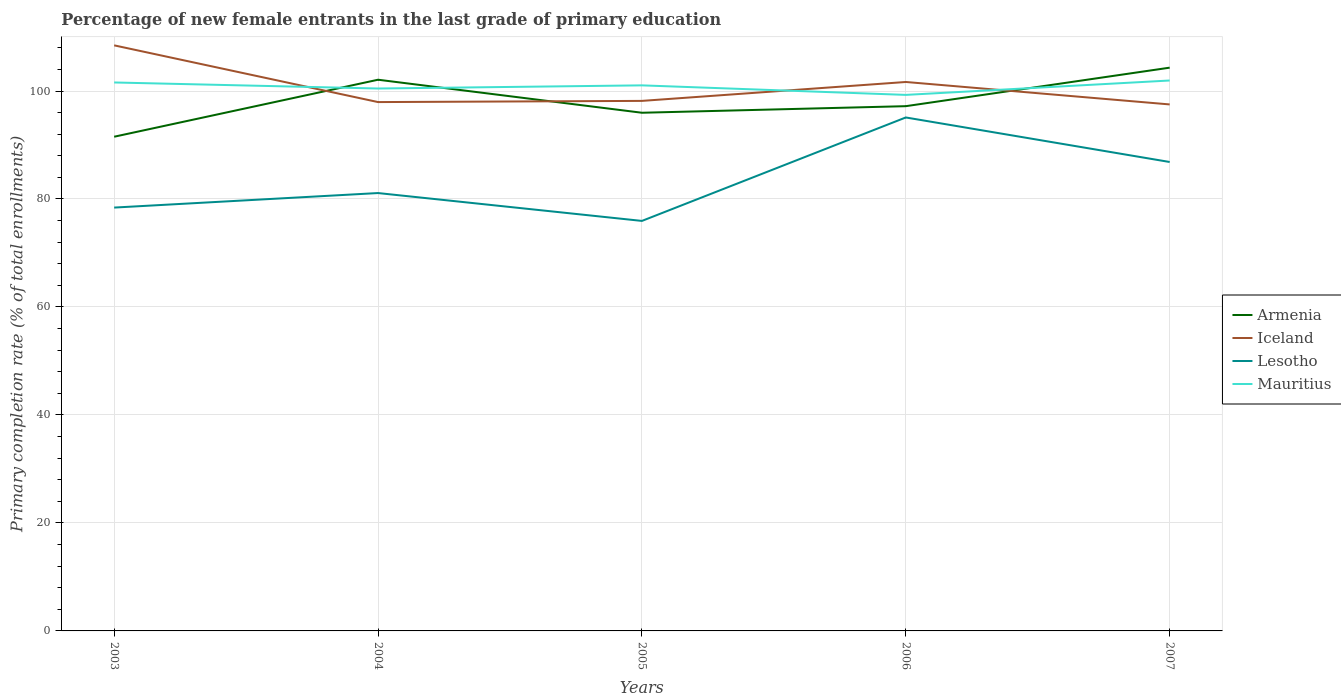Does the line corresponding to Iceland intersect with the line corresponding to Armenia?
Your answer should be very brief. Yes. Is the number of lines equal to the number of legend labels?
Make the answer very short. Yes. Across all years, what is the maximum percentage of new female entrants in Lesotho?
Ensure brevity in your answer.  75.94. In which year was the percentage of new female entrants in Lesotho maximum?
Offer a very short reply. 2005. What is the total percentage of new female entrants in Mauritius in the graph?
Your answer should be very brief. -2.67. What is the difference between the highest and the second highest percentage of new female entrants in Iceland?
Provide a short and direct response. 10.94. What is the difference between the highest and the lowest percentage of new female entrants in Lesotho?
Give a very brief answer. 2. How many years are there in the graph?
Offer a terse response. 5. What is the difference between two consecutive major ticks on the Y-axis?
Your answer should be compact. 20. Are the values on the major ticks of Y-axis written in scientific E-notation?
Your answer should be compact. No. Does the graph contain any zero values?
Your answer should be compact. No. Does the graph contain grids?
Your response must be concise. Yes. How many legend labels are there?
Give a very brief answer. 4. How are the legend labels stacked?
Offer a terse response. Vertical. What is the title of the graph?
Provide a succinct answer. Percentage of new female entrants in the last grade of primary education. What is the label or title of the X-axis?
Keep it short and to the point. Years. What is the label or title of the Y-axis?
Offer a terse response. Primary completion rate (% of total enrollments). What is the Primary completion rate (% of total enrollments) of Armenia in 2003?
Offer a terse response. 91.53. What is the Primary completion rate (% of total enrollments) of Iceland in 2003?
Offer a terse response. 108.46. What is the Primary completion rate (% of total enrollments) in Lesotho in 2003?
Ensure brevity in your answer.  78.41. What is the Primary completion rate (% of total enrollments) of Mauritius in 2003?
Give a very brief answer. 101.58. What is the Primary completion rate (% of total enrollments) in Armenia in 2004?
Offer a very short reply. 102.09. What is the Primary completion rate (% of total enrollments) of Iceland in 2004?
Offer a very short reply. 97.95. What is the Primary completion rate (% of total enrollments) of Lesotho in 2004?
Your answer should be compact. 81.1. What is the Primary completion rate (% of total enrollments) in Mauritius in 2004?
Keep it short and to the point. 100.46. What is the Primary completion rate (% of total enrollments) of Armenia in 2005?
Keep it short and to the point. 95.97. What is the Primary completion rate (% of total enrollments) of Iceland in 2005?
Your answer should be very brief. 98.17. What is the Primary completion rate (% of total enrollments) in Lesotho in 2005?
Your response must be concise. 75.94. What is the Primary completion rate (% of total enrollments) in Mauritius in 2005?
Offer a terse response. 101.05. What is the Primary completion rate (% of total enrollments) in Armenia in 2006?
Provide a short and direct response. 97.19. What is the Primary completion rate (% of total enrollments) of Iceland in 2006?
Offer a terse response. 101.67. What is the Primary completion rate (% of total enrollments) in Lesotho in 2006?
Give a very brief answer. 95.1. What is the Primary completion rate (% of total enrollments) of Mauritius in 2006?
Provide a succinct answer. 99.28. What is the Primary completion rate (% of total enrollments) in Armenia in 2007?
Your answer should be very brief. 104.33. What is the Primary completion rate (% of total enrollments) of Iceland in 2007?
Your response must be concise. 97.52. What is the Primary completion rate (% of total enrollments) of Lesotho in 2007?
Your response must be concise. 86.85. What is the Primary completion rate (% of total enrollments) in Mauritius in 2007?
Provide a short and direct response. 101.95. Across all years, what is the maximum Primary completion rate (% of total enrollments) in Armenia?
Your answer should be very brief. 104.33. Across all years, what is the maximum Primary completion rate (% of total enrollments) in Iceland?
Provide a short and direct response. 108.46. Across all years, what is the maximum Primary completion rate (% of total enrollments) in Lesotho?
Your response must be concise. 95.1. Across all years, what is the maximum Primary completion rate (% of total enrollments) in Mauritius?
Keep it short and to the point. 101.95. Across all years, what is the minimum Primary completion rate (% of total enrollments) of Armenia?
Provide a succinct answer. 91.53. Across all years, what is the minimum Primary completion rate (% of total enrollments) in Iceland?
Provide a short and direct response. 97.52. Across all years, what is the minimum Primary completion rate (% of total enrollments) of Lesotho?
Offer a very short reply. 75.94. Across all years, what is the minimum Primary completion rate (% of total enrollments) of Mauritius?
Provide a short and direct response. 99.28. What is the total Primary completion rate (% of total enrollments) of Armenia in the graph?
Offer a terse response. 491.12. What is the total Primary completion rate (% of total enrollments) of Iceland in the graph?
Your answer should be compact. 503.77. What is the total Primary completion rate (% of total enrollments) in Lesotho in the graph?
Ensure brevity in your answer.  417.41. What is the total Primary completion rate (% of total enrollments) in Mauritius in the graph?
Offer a very short reply. 504.32. What is the difference between the Primary completion rate (% of total enrollments) of Armenia in 2003 and that in 2004?
Offer a terse response. -10.56. What is the difference between the Primary completion rate (% of total enrollments) of Iceland in 2003 and that in 2004?
Your answer should be compact. 10.51. What is the difference between the Primary completion rate (% of total enrollments) in Lesotho in 2003 and that in 2004?
Offer a terse response. -2.69. What is the difference between the Primary completion rate (% of total enrollments) in Mauritius in 2003 and that in 2004?
Your answer should be very brief. 1.12. What is the difference between the Primary completion rate (% of total enrollments) in Armenia in 2003 and that in 2005?
Your answer should be compact. -4.44. What is the difference between the Primary completion rate (% of total enrollments) in Iceland in 2003 and that in 2005?
Make the answer very short. 10.29. What is the difference between the Primary completion rate (% of total enrollments) of Lesotho in 2003 and that in 2005?
Offer a terse response. 2.47. What is the difference between the Primary completion rate (% of total enrollments) of Mauritius in 2003 and that in 2005?
Make the answer very short. 0.53. What is the difference between the Primary completion rate (% of total enrollments) of Armenia in 2003 and that in 2006?
Provide a short and direct response. -5.66. What is the difference between the Primary completion rate (% of total enrollments) in Iceland in 2003 and that in 2006?
Offer a very short reply. 6.78. What is the difference between the Primary completion rate (% of total enrollments) in Lesotho in 2003 and that in 2006?
Your answer should be very brief. -16.69. What is the difference between the Primary completion rate (% of total enrollments) of Mauritius in 2003 and that in 2006?
Provide a short and direct response. 2.3. What is the difference between the Primary completion rate (% of total enrollments) in Armenia in 2003 and that in 2007?
Give a very brief answer. -12.79. What is the difference between the Primary completion rate (% of total enrollments) in Iceland in 2003 and that in 2007?
Offer a terse response. 10.94. What is the difference between the Primary completion rate (% of total enrollments) in Lesotho in 2003 and that in 2007?
Make the answer very short. -8.44. What is the difference between the Primary completion rate (% of total enrollments) of Mauritius in 2003 and that in 2007?
Offer a terse response. -0.36. What is the difference between the Primary completion rate (% of total enrollments) of Armenia in 2004 and that in 2005?
Your answer should be very brief. 6.12. What is the difference between the Primary completion rate (% of total enrollments) in Iceland in 2004 and that in 2005?
Your answer should be compact. -0.22. What is the difference between the Primary completion rate (% of total enrollments) in Lesotho in 2004 and that in 2005?
Provide a short and direct response. 5.16. What is the difference between the Primary completion rate (% of total enrollments) of Mauritius in 2004 and that in 2005?
Your response must be concise. -0.59. What is the difference between the Primary completion rate (% of total enrollments) in Armenia in 2004 and that in 2006?
Your answer should be compact. 4.9. What is the difference between the Primary completion rate (% of total enrollments) of Iceland in 2004 and that in 2006?
Provide a succinct answer. -3.72. What is the difference between the Primary completion rate (% of total enrollments) in Lesotho in 2004 and that in 2006?
Make the answer very short. -14. What is the difference between the Primary completion rate (% of total enrollments) in Mauritius in 2004 and that in 2006?
Offer a terse response. 1.18. What is the difference between the Primary completion rate (% of total enrollments) of Armenia in 2004 and that in 2007?
Make the answer very short. -2.23. What is the difference between the Primary completion rate (% of total enrollments) of Iceland in 2004 and that in 2007?
Your response must be concise. 0.44. What is the difference between the Primary completion rate (% of total enrollments) of Lesotho in 2004 and that in 2007?
Ensure brevity in your answer.  -5.75. What is the difference between the Primary completion rate (% of total enrollments) of Mauritius in 2004 and that in 2007?
Your answer should be very brief. -1.48. What is the difference between the Primary completion rate (% of total enrollments) in Armenia in 2005 and that in 2006?
Offer a terse response. -1.22. What is the difference between the Primary completion rate (% of total enrollments) in Iceland in 2005 and that in 2006?
Give a very brief answer. -3.5. What is the difference between the Primary completion rate (% of total enrollments) in Lesotho in 2005 and that in 2006?
Give a very brief answer. -19.16. What is the difference between the Primary completion rate (% of total enrollments) in Mauritius in 2005 and that in 2006?
Make the answer very short. 1.77. What is the difference between the Primary completion rate (% of total enrollments) of Armenia in 2005 and that in 2007?
Offer a terse response. -8.35. What is the difference between the Primary completion rate (% of total enrollments) in Iceland in 2005 and that in 2007?
Keep it short and to the point. 0.65. What is the difference between the Primary completion rate (% of total enrollments) of Lesotho in 2005 and that in 2007?
Your answer should be very brief. -10.91. What is the difference between the Primary completion rate (% of total enrollments) in Mauritius in 2005 and that in 2007?
Provide a succinct answer. -0.9. What is the difference between the Primary completion rate (% of total enrollments) in Armenia in 2006 and that in 2007?
Offer a very short reply. -7.13. What is the difference between the Primary completion rate (% of total enrollments) of Iceland in 2006 and that in 2007?
Provide a succinct answer. 4.16. What is the difference between the Primary completion rate (% of total enrollments) in Lesotho in 2006 and that in 2007?
Your answer should be compact. 8.25. What is the difference between the Primary completion rate (% of total enrollments) of Mauritius in 2006 and that in 2007?
Your response must be concise. -2.67. What is the difference between the Primary completion rate (% of total enrollments) of Armenia in 2003 and the Primary completion rate (% of total enrollments) of Iceland in 2004?
Offer a terse response. -6.42. What is the difference between the Primary completion rate (% of total enrollments) of Armenia in 2003 and the Primary completion rate (% of total enrollments) of Lesotho in 2004?
Your answer should be compact. 10.43. What is the difference between the Primary completion rate (% of total enrollments) in Armenia in 2003 and the Primary completion rate (% of total enrollments) in Mauritius in 2004?
Ensure brevity in your answer.  -8.93. What is the difference between the Primary completion rate (% of total enrollments) in Iceland in 2003 and the Primary completion rate (% of total enrollments) in Lesotho in 2004?
Offer a terse response. 27.36. What is the difference between the Primary completion rate (% of total enrollments) in Iceland in 2003 and the Primary completion rate (% of total enrollments) in Mauritius in 2004?
Your answer should be compact. 8. What is the difference between the Primary completion rate (% of total enrollments) of Lesotho in 2003 and the Primary completion rate (% of total enrollments) of Mauritius in 2004?
Offer a very short reply. -22.05. What is the difference between the Primary completion rate (% of total enrollments) in Armenia in 2003 and the Primary completion rate (% of total enrollments) in Iceland in 2005?
Your answer should be compact. -6.64. What is the difference between the Primary completion rate (% of total enrollments) of Armenia in 2003 and the Primary completion rate (% of total enrollments) of Lesotho in 2005?
Offer a terse response. 15.59. What is the difference between the Primary completion rate (% of total enrollments) in Armenia in 2003 and the Primary completion rate (% of total enrollments) in Mauritius in 2005?
Offer a terse response. -9.51. What is the difference between the Primary completion rate (% of total enrollments) of Iceland in 2003 and the Primary completion rate (% of total enrollments) of Lesotho in 2005?
Give a very brief answer. 32.52. What is the difference between the Primary completion rate (% of total enrollments) in Iceland in 2003 and the Primary completion rate (% of total enrollments) in Mauritius in 2005?
Offer a very short reply. 7.41. What is the difference between the Primary completion rate (% of total enrollments) in Lesotho in 2003 and the Primary completion rate (% of total enrollments) in Mauritius in 2005?
Give a very brief answer. -22.64. What is the difference between the Primary completion rate (% of total enrollments) of Armenia in 2003 and the Primary completion rate (% of total enrollments) of Iceland in 2006?
Offer a terse response. -10.14. What is the difference between the Primary completion rate (% of total enrollments) of Armenia in 2003 and the Primary completion rate (% of total enrollments) of Lesotho in 2006?
Offer a terse response. -3.57. What is the difference between the Primary completion rate (% of total enrollments) in Armenia in 2003 and the Primary completion rate (% of total enrollments) in Mauritius in 2006?
Give a very brief answer. -7.75. What is the difference between the Primary completion rate (% of total enrollments) in Iceland in 2003 and the Primary completion rate (% of total enrollments) in Lesotho in 2006?
Make the answer very short. 13.36. What is the difference between the Primary completion rate (% of total enrollments) of Iceland in 2003 and the Primary completion rate (% of total enrollments) of Mauritius in 2006?
Offer a terse response. 9.18. What is the difference between the Primary completion rate (% of total enrollments) of Lesotho in 2003 and the Primary completion rate (% of total enrollments) of Mauritius in 2006?
Provide a succinct answer. -20.87. What is the difference between the Primary completion rate (% of total enrollments) of Armenia in 2003 and the Primary completion rate (% of total enrollments) of Iceland in 2007?
Your response must be concise. -5.98. What is the difference between the Primary completion rate (% of total enrollments) of Armenia in 2003 and the Primary completion rate (% of total enrollments) of Lesotho in 2007?
Your response must be concise. 4.68. What is the difference between the Primary completion rate (% of total enrollments) of Armenia in 2003 and the Primary completion rate (% of total enrollments) of Mauritius in 2007?
Your response must be concise. -10.41. What is the difference between the Primary completion rate (% of total enrollments) in Iceland in 2003 and the Primary completion rate (% of total enrollments) in Lesotho in 2007?
Give a very brief answer. 21.6. What is the difference between the Primary completion rate (% of total enrollments) of Iceland in 2003 and the Primary completion rate (% of total enrollments) of Mauritius in 2007?
Your response must be concise. 6.51. What is the difference between the Primary completion rate (% of total enrollments) in Lesotho in 2003 and the Primary completion rate (% of total enrollments) in Mauritius in 2007?
Provide a short and direct response. -23.54. What is the difference between the Primary completion rate (% of total enrollments) in Armenia in 2004 and the Primary completion rate (% of total enrollments) in Iceland in 2005?
Provide a short and direct response. 3.92. What is the difference between the Primary completion rate (% of total enrollments) of Armenia in 2004 and the Primary completion rate (% of total enrollments) of Lesotho in 2005?
Your answer should be very brief. 26.15. What is the difference between the Primary completion rate (% of total enrollments) in Armenia in 2004 and the Primary completion rate (% of total enrollments) in Mauritius in 2005?
Your answer should be very brief. 1.04. What is the difference between the Primary completion rate (% of total enrollments) of Iceland in 2004 and the Primary completion rate (% of total enrollments) of Lesotho in 2005?
Provide a short and direct response. 22.01. What is the difference between the Primary completion rate (% of total enrollments) of Iceland in 2004 and the Primary completion rate (% of total enrollments) of Mauritius in 2005?
Your answer should be very brief. -3.1. What is the difference between the Primary completion rate (% of total enrollments) in Lesotho in 2004 and the Primary completion rate (% of total enrollments) in Mauritius in 2005?
Make the answer very short. -19.95. What is the difference between the Primary completion rate (% of total enrollments) in Armenia in 2004 and the Primary completion rate (% of total enrollments) in Iceland in 2006?
Your answer should be compact. 0.42. What is the difference between the Primary completion rate (% of total enrollments) in Armenia in 2004 and the Primary completion rate (% of total enrollments) in Lesotho in 2006?
Your answer should be very brief. 6.99. What is the difference between the Primary completion rate (% of total enrollments) of Armenia in 2004 and the Primary completion rate (% of total enrollments) of Mauritius in 2006?
Offer a terse response. 2.81. What is the difference between the Primary completion rate (% of total enrollments) in Iceland in 2004 and the Primary completion rate (% of total enrollments) in Lesotho in 2006?
Offer a terse response. 2.85. What is the difference between the Primary completion rate (% of total enrollments) of Iceland in 2004 and the Primary completion rate (% of total enrollments) of Mauritius in 2006?
Offer a terse response. -1.33. What is the difference between the Primary completion rate (% of total enrollments) in Lesotho in 2004 and the Primary completion rate (% of total enrollments) in Mauritius in 2006?
Your response must be concise. -18.18. What is the difference between the Primary completion rate (% of total enrollments) in Armenia in 2004 and the Primary completion rate (% of total enrollments) in Iceland in 2007?
Provide a succinct answer. 4.58. What is the difference between the Primary completion rate (% of total enrollments) in Armenia in 2004 and the Primary completion rate (% of total enrollments) in Lesotho in 2007?
Give a very brief answer. 15.24. What is the difference between the Primary completion rate (% of total enrollments) of Armenia in 2004 and the Primary completion rate (% of total enrollments) of Mauritius in 2007?
Offer a terse response. 0.14. What is the difference between the Primary completion rate (% of total enrollments) of Iceland in 2004 and the Primary completion rate (% of total enrollments) of Lesotho in 2007?
Provide a short and direct response. 11.1. What is the difference between the Primary completion rate (% of total enrollments) of Iceland in 2004 and the Primary completion rate (% of total enrollments) of Mauritius in 2007?
Ensure brevity in your answer.  -4. What is the difference between the Primary completion rate (% of total enrollments) of Lesotho in 2004 and the Primary completion rate (% of total enrollments) of Mauritius in 2007?
Your answer should be very brief. -20.85. What is the difference between the Primary completion rate (% of total enrollments) in Armenia in 2005 and the Primary completion rate (% of total enrollments) in Iceland in 2006?
Ensure brevity in your answer.  -5.7. What is the difference between the Primary completion rate (% of total enrollments) in Armenia in 2005 and the Primary completion rate (% of total enrollments) in Lesotho in 2006?
Offer a very short reply. 0.87. What is the difference between the Primary completion rate (% of total enrollments) in Armenia in 2005 and the Primary completion rate (% of total enrollments) in Mauritius in 2006?
Offer a terse response. -3.31. What is the difference between the Primary completion rate (% of total enrollments) in Iceland in 2005 and the Primary completion rate (% of total enrollments) in Lesotho in 2006?
Keep it short and to the point. 3.07. What is the difference between the Primary completion rate (% of total enrollments) in Iceland in 2005 and the Primary completion rate (% of total enrollments) in Mauritius in 2006?
Give a very brief answer. -1.11. What is the difference between the Primary completion rate (% of total enrollments) in Lesotho in 2005 and the Primary completion rate (% of total enrollments) in Mauritius in 2006?
Offer a very short reply. -23.34. What is the difference between the Primary completion rate (% of total enrollments) of Armenia in 2005 and the Primary completion rate (% of total enrollments) of Iceland in 2007?
Offer a very short reply. -1.54. What is the difference between the Primary completion rate (% of total enrollments) of Armenia in 2005 and the Primary completion rate (% of total enrollments) of Lesotho in 2007?
Ensure brevity in your answer.  9.12. What is the difference between the Primary completion rate (% of total enrollments) in Armenia in 2005 and the Primary completion rate (% of total enrollments) in Mauritius in 2007?
Provide a succinct answer. -5.97. What is the difference between the Primary completion rate (% of total enrollments) of Iceland in 2005 and the Primary completion rate (% of total enrollments) of Lesotho in 2007?
Your answer should be very brief. 11.32. What is the difference between the Primary completion rate (% of total enrollments) in Iceland in 2005 and the Primary completion rate (% of total enrollments) in Mauritius in 2007?
Your response must be concise. -3.78. What is the difference between the Primary completion rate (% of total enrollments) of Lesotho in 2005 and the Primary completion rate (% of total enrollments) of Mauritius in 2007?
Provide a short and direct response. -26.01. What is the difference between the Primary completion rate (% of total enrollments) in Armenia in 2006 and the Primary completion rate (% of total enrollments) in Iceland in 2007?
Offer a terse response. -0.32. What is the difference between the Primary completion rate (% of total enrollments) of Armenia in 2006 and the Primary completion rate (% of total enrollments) of Lesotho in 2007?
Ensure brevity in your answer.  10.34. What is the difference between the Primary completion rate (% of total enrollments) of Armenia in 2006 and the Primary completion rate (% of total enrollments) of Mauritius in 2007?
Offer a very short reply. -4.75. What is the difference between the Primary completion rate (% of total enrollments) in Iceland in 2006 and the Primary completion rate (% of total enrollments) in Lesotho in 2007?
Offer a very short reply. 14.82. What is the difference between the Primary completion rate (% of total enrollments) in Iceland in 2006 and the Primary completion rate (% of total enrollments) in Mauritius in 2007?
Your answer should be compact. -0.27. What is the difference between the Primary completion rate (% of total enrollments) in Lesotho in 2006 and the Primary completion rate (% of total enrollments) in Mauritius in 2007?
Keep it short and to the point. -6.85. What is the average Primary completion rate (% of total enrollments) in Armenia per year?
Offer a terse response. 98.22. What is the average Primary completion rate (% of total enrollments) of Iceland per year?
Provide a succinct answer. 100.75. What is the average Primary completion rate (% of total enrollments) of Lesotho per year?
Offer a terse response. 83.48. What is the average Primary completion rate (% of total enrollments) of Mauritius per year?
Offer a very short reply. 100.86. In the year 2003, what is the difference between the Primary completion rate (% of total enrollments) of Armenia and Primary completion rate (% of total enrollments) of Iceland?
Provide a succinct answer. -16.92. In the year 2003, what is the difference between the Primary completion rate (% of total enrollments) of Armenia and Primary completion rate (% of total enrollments) of Lesotho?
Provide a succinct answer. 13.12. In the year 2003, what is the difference between the Primary completion rate (% of total enrollments) in Armenia and Primary completion rate (% of total enrollments) in Mauritius?
Offer a terse response. -10.05. In the year 2003, what is the difference between the Primary completion rate (% of total enrollments) of Iceland and Primary completion rate (% of total enrollments) of Lesotho?
Make the answer very short. 30.05. In the year 2003, what is the difference between the Primary completion rate (% of total enrollments) in Iceland and Primary completion rate (% of total enrollments) in Mauritius?
Provide a short and direct response. 6.88. In the year 2003, what is the difference between the Primary completion rate (% of total enrollments) in Lesotho and Primary completion rate (% of total enrollments) in Mauritius?
Provide a succinct answer. -23.17. In the year 2004, what is the difference between the Primary completion rate (% of total enrollments) of Armenia and Primary completion rate (% of total enrollments) of Iceland?
Keep it short and to the point. 4.14. In the year 2004, what is the difference between the Primary completion rate (% of total enrollments) of Armenia and Primary completion rate (% of total enrollments) of Lesotho?
Your answer should be very brief. 20.99. In the year 2004, what is the difference between the Primary completion rate (% of total enrollments) of Armenia and Primary completion rate (% of total enrollments) of Mauritius?
Give a very brief answer. 1.63. In the year 2004, what is the difference between the Primary completion rate (% of total enrollments) of Iceland and Primary completion rate (% of total enrollments) of Lesotho?
Ensure brevity in your answer.  16.85. In the year 2004, what is the difference between the Primary completion rate (% of total enrollments) of Iceland and Primary completion rate (% of total enrollments) of Mauritius?
Your response must be concise. -2.51. In the year 2004, what is the difference between the Primary completion rate (% of total enrollments) in Lesotho and Primary completion rate (% of total enrollments) in Mauritius?
Ensure brevity in your answer.  -19.36. In the year 2005, what is the difference between the Primary completion rate (% of total enrollments) in Armenia and Primary completion rate (% of total enrollments) in Iceland?
Keep it short and to the point. -2.2. In the year 2005, what is the difference between the Primary completion rate (% of total enrollments) in Armenia and Primary completion rate (% of total enrollments) in Lesotho?
Give a very brief answer. 20.03. In the year 2005, what is the difference between the Primary completion rate (% of total enrollments) of Armenia and Primary completion rate (% of total enrollments) of Mauritius?
Your response must be concise. -5.07. In the year 2005, what is the difference between the Primary completion rate (% of total enrollments) in Iceland and Primary completion rate (% of total enrollments) in Lesotho?
Offer a terse response. 22.23. In the year 2005, what is the difference between the Primary completion rate (% of total enrollments) of Iceland and Primary completion rate (% of total enrollments) of Mauritius?
Keep it short and to the point. -2.88. In the year 2005, what is the difference between the Primary completion rate (% of total enrollments) of Lesotho and Primary completion rate (% of total enrollments) of Mauritius?
Make the answer very short. -25.11. In the year 2006, what is the difference between the Primary completion rate (% of total enrollments) in Armenia and Primary completion rate (% of total enrollments) in Iceland?
Your response must be concise. -4.48. In the year 2006, what is the difference between the Primary completion rate (% of total enrollments) of Armenia and Primary completion rate (% of total enrollments) of Lesotho?
Offer a terse response. 2.09. In the year 2006, what is the difference between the Primary completion rate (% of total enrollments) in Armenia and Primary completion rate (% of total enrollments) in Mauritius?
Offer a very short reply. -2.09. In the year 2006, what is the difference between the Primary completion rate (% of total enrollments) of Iceland and Primary completion rate (% of total enrollments) of Lesotho?
Keep it short and to the point. 6.57. In the year 2006, what is the difference between the Primary completion rate (% of total enrollments) of Iceland and Primary completion rate (% of total enrollments) of Mauritius?
Provide a succinct answer. 2.39. In the year 2006, what is the difference between the Primary completion rate (% of total enrollments) of Lesotho and Primary completion rate (% of total enrollments) of Mauritius?
Make the answer very short. -4.18. In the year 2007, what is the difference between the Primary completion rate (% of total enrollments) of Armenia and Primary completion rate (% of total enrollments) of Iceland?
Give a very brief answer. 6.81. In the year 2007, what is the difference between the Primary completion rate (% of total enrollments) in Armenia and Primary completion rate (% of total enrollments) in Lesotho?
Give a very brief answer. 17.47. In the year 2007, what is the difference between the Primary completion rate (% of total enrollments) in Armenia and Primary completion rate (% of total enrollments) in Mauritius?
Keep it short and to the point. 2.38. In the year 2007, what is the difference between the Primary completion rate (% of total enrollments) of Iceland and Primary completion rate (% of total enrollments) of Lesotho?
Make the answer very short. 10.66. In the year 2007, what is the difference between the Primary completion rate (% of total enrollments) of Iceland and Primary completion rate (% of total enrollments) of Mauritius?
Ensure brevity in your answer.  -4.43. In the year 2007, what is the difference between the Primary completion rate (% of total enrollments) in Lesotho and Primary completion rate (% of total enrollments) in Mauritius?
Provide a short and direct response. -15.09. What is the ratio of the Primary completion rate (% of total enrollments) in Armenia in 2003 to that in 2004?
Your answer should be compact. 0.9. What is the ratio of the Primary completion rate (% of total enrollments) of Iceland in 2003 to that in 2004?
Offer a terse response. 1.11. What is the ratio of the Primary completion rate (% of total enrollments) of Lesotho in 2003 to that in 2004?
Keep it short and to the point. 0.97. What is the ratio of the Primary completion rate (% of total enrollments) of Mauritius in 2003 to that in 2004?
Your response must be concise. 1.01. What is the ratio of the Primary completion rate (% of total enrollments) of Armenia in 2003 to that in 2005?
Your answer should be very brief. 0.95. What is the ratio of the Primary completion rate (% of total enrollments) in Iceland in 2003 to that in 2005?
Make the answer very short. 1.1. What is the ratio of the Primary completion rate (% of total enrollments) in Lesotho in 2003 to that in 2005?
Ensure brevity in your answer.  1.03. What is the ratio of the Primary completion rate (% of total enrollments) in Armenia in 2003 to that in 2006?
Your response must be concise. 0.94. What is the ratio of the Primary completion rate (% of total enrollments) in Iceland in 2003 to that in 2006?
Offer a very short reply. 1.07. What is the ratio of the Primary completion rate (% of total enrollments) of Lesotho in 2003 to that in 2006?
Make the answer very short. 0.82. What is the ratio of the Primary completion rate (% of total enrollments) in Mauritius in 2003 to that in 2006?
Make the answer very short. 1.02. What is the ratio of the Primary completion rate (% of total enrollments) in Armenia in 2003 to that in 2007?
Your answer should be compact. 0.88. What is the ratio of the Primary completion rate (% of total enrollments) in Iceland in 2003 to that in 2007?
Provide a short and direct response. 1.11. What is the ratio of the Primary completion rate (% of total enrollments) of Lesotho in 2003 to that in 2007?
Offer a very short reply. 0.9. What is the ratio of the Primary completion rate (% of total enrollments) of Armenia in 2004 to that in 2005?
Give a very brief answer. 1.06. What is the ratio of the Primary completion rate (% of total enrollments) of Iceland in 2004 to that in 2005?
Provide a succinct answer. 1. What is the ratio of the Primary completion rate (% of total enrollments) in Lesotho in 2004 to that in 2005?
Provide a succinct answer. 1.07. What is the ratio of the Primary completion rate (% of total enrollments) of Mauritius in 2004 to that in 2005?
Give a very brief answer. 0.99. What is the ratio of the Primary completion rate (% of total enrollments) of Armenia in 2004 to that in 2006?
Your answer should be compact. 1.05. What is the ratio of the Primary completion rate (% of total enrollments) of Iceland in 2004 to that in 2006?
Make the answer very short. 0.96. What is the ratio of the Primary completion rate (% of total enrollments) of Lesotho in 2004 to that in 2006?
Offer a very short reply. 0.85. What is the ratio of the Primary completion rate (% of total enrollments) of Mauritius in 2004 to that in 2006?
Your answer should be compact. 1.01. What is the ratio of the Primary completion rate (% of total enrollments) in Armenia in 2004 to that in 2007?
Provide a short and direct response. 0.98. What is the ratio of the Primary completion rate (% of total enrollments) of Iceland in 2004 to that in 2007?
Offer a terse response. 1. What is the ratio of the Primary completion rate (% of total enrollments) of Lesotho in 2004 to that in 2007?
Offer a terse response. 0.93. What is the ratio of the Primary completion rate (% of total enrollments) in Mauritius in 2004 to that in 2007?
Ensure brevity in your answer.  0.99. What is the ratio of the Primary completion rate (% of total enrollments) in Armenia in 2005 to that in 2006?
Make the answer very short. 0.99. What is the ratio of the Primary completion rate (% of total enrollments) of Iceland in 2005 to that in 2006?
Keep it short and to the point. 0.97. What is the ratio of the Primary completion rate (% of total enrollments) of Lesotho in 2005 to that in 2006?
Give a very brief answer. 0.8. What is the ratio of the Primary completion rate (% of total enrollments) in Mauritius in 2005 to that in 2006?
Offer a terse response. 1.02. What is the ratio of the Primary completion rate (% of total enrollments) of Iceland in 2005 to that in 2007?
Offer a terse response. 1.01. What is the ratio of the Primary completion rate (% of total enrollments) of Lesotho in 2005 to that in 2007?
Your response must be concise. 0.87. What is the ratio of the Primary completion rate (% of total enrollments) in Mauritius in 2005 to that in 2007?
Provide a succinct answer. 0.99. What is the ratio of the Primary completion rate (% of total enrollments) in Armenia in 2006 to that in 2007?
Ensure brevity in your answer.  0.93. What is the ratio of the Primary completion rate (% of total enrollments) in Iceland in 2006 to that in 2007?
Provide a succinct answer. 1.04. What is the ratio of the Primary completion rate (% of total enrollments) of Lesotho in 2006 to that in 2007?
Your response must be concise. 1.09. What is the ratio of the Primary completion rate (% of total enrollments) of Mauritius in 2006 to that in 2007?
Provide a succinct answer. 0.97. What is the difference between the highest and the second highest Primary completion rate (% of total enrollments) in Armenia?
Your answer should be compact. 2.23. What is the difference between the highest and the second highest Primary completion rate (% of total enrollments) in Iceland?
Provide a succinct answer. 6.78. What is the difference between the highest and the second highest Primary completion rate (% of total enrollments) in Lesotho?
Your response must be concise. 8.25. What is the difference between the highest and the second highest Primary completion rate (% of total enrollments) of Mauritius?
Offer a terse response. 0.36. What is the difference between the highest and the lowest Primary completion rate (% of total enrollments) of Armenia?
Offer a terse response. 12.79. What is the difference between the highest and the lowest Primary completion rate (% of total enrollments) in Iceland?
Give a very brief answer. 10.94. What is the difference between the highest and the lowest Primary completion rate (% of total enrollments) in Lesotho?
Give a very brief answer. 19.16. What is the difference between the highest and the lowest Primary completion rate (% of total enrollments) of Mauritius?
Your response must be concise. 2.67. 